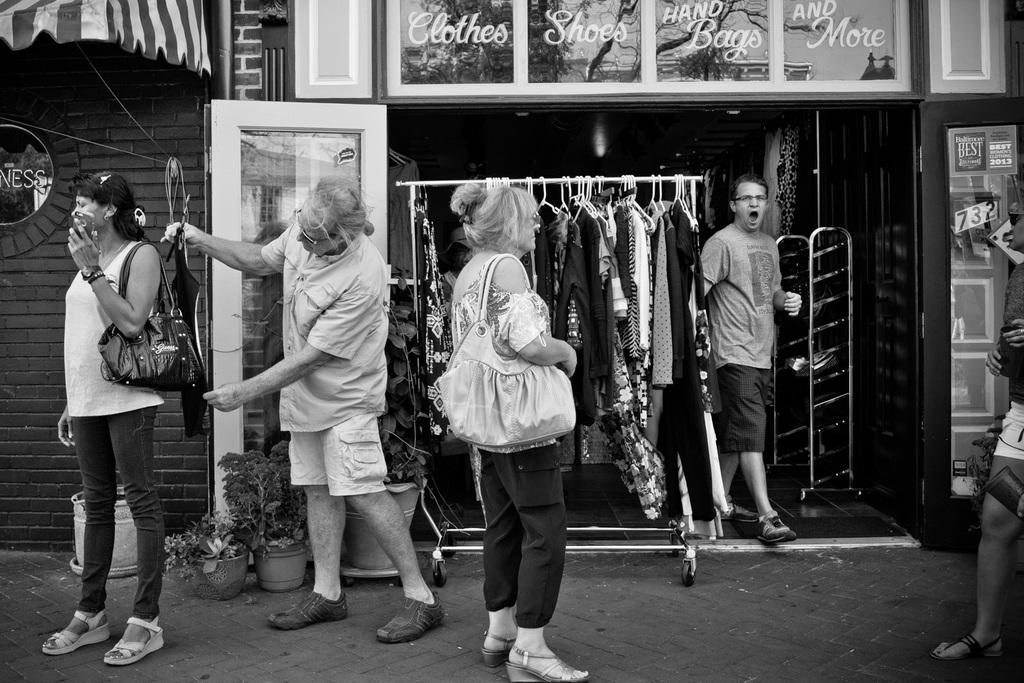What is happening in the middle of the image? There are people standing in the middle of the image. What can be seen on the left side of the image? There are plant pots on the left side of the image. What is visible in the background of the image? Clothes are visible in the background of the image. Where might this image have been taken? The image appears to be taken in a store. How does the sheet of paper relate to the people standing in the image? There is no sheet of paper present in the image. What type of test is being conducted in the image? There is no test being conducted in the image; it features people standing near plant pots in a store. 